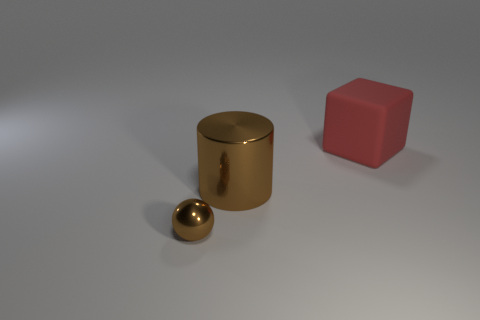Add 1 small green shiny spheres. How many objects exist? 4 Subtract all cubes. How many objects are left? 2 Subtract all shiny balls. Subtract all matte objects. How many objects are left? 1 Add 3 small brown spheres. How many small brown spheres are left? 4 Add 1 small metal spheres. How many small metal spheres exist? 2 Subtract 0 cyan cylinders. How many objects are left? 3 